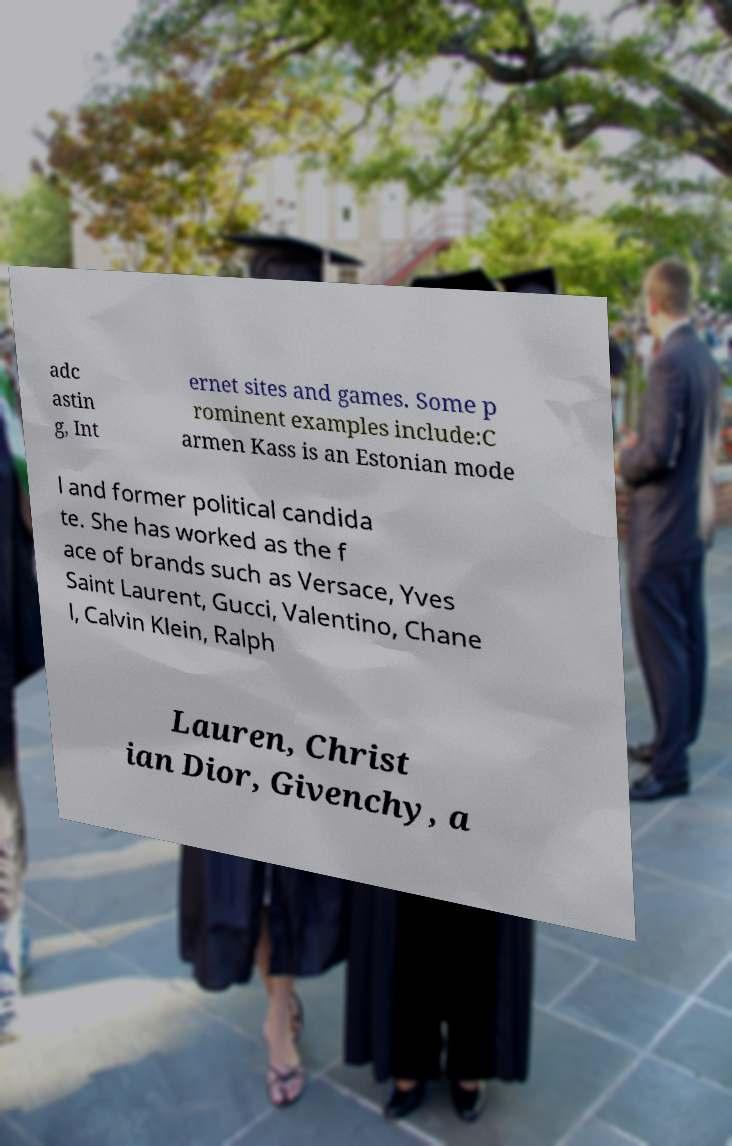Could you assist in decoding the text presented in this image and type it out clearly? adc astin g, Int ernet sites and games. Some p rominent examples include:C armen Kass is an Estonian mode l and former political candida te. She has worked as the f ace of brands such as Versace, Yves Saint Laurent, Gucci, Valentino, Chane l, Calvin Klein, Ralph Lauren, Christ ian Dior, Givenchy, a 